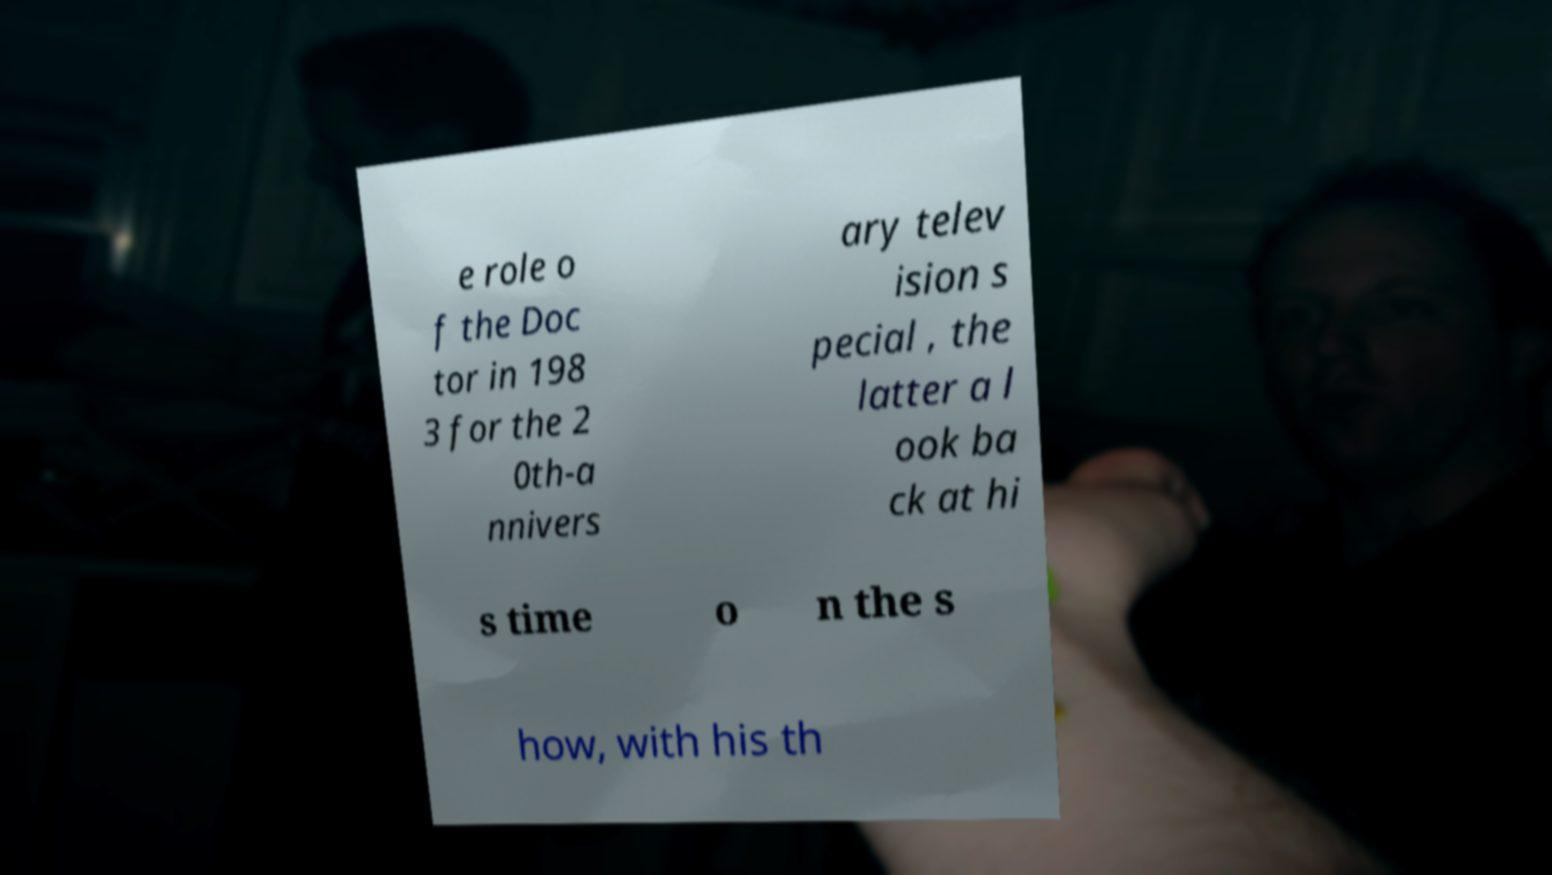Can you accurately transcribe the text from the provided image for me? e role o f the Doc tor in 198 3 for the 2 0th-a nnivers ary telev ision s pecial , the latter a l ook ba ck at hi s time o n the s how, with his th 